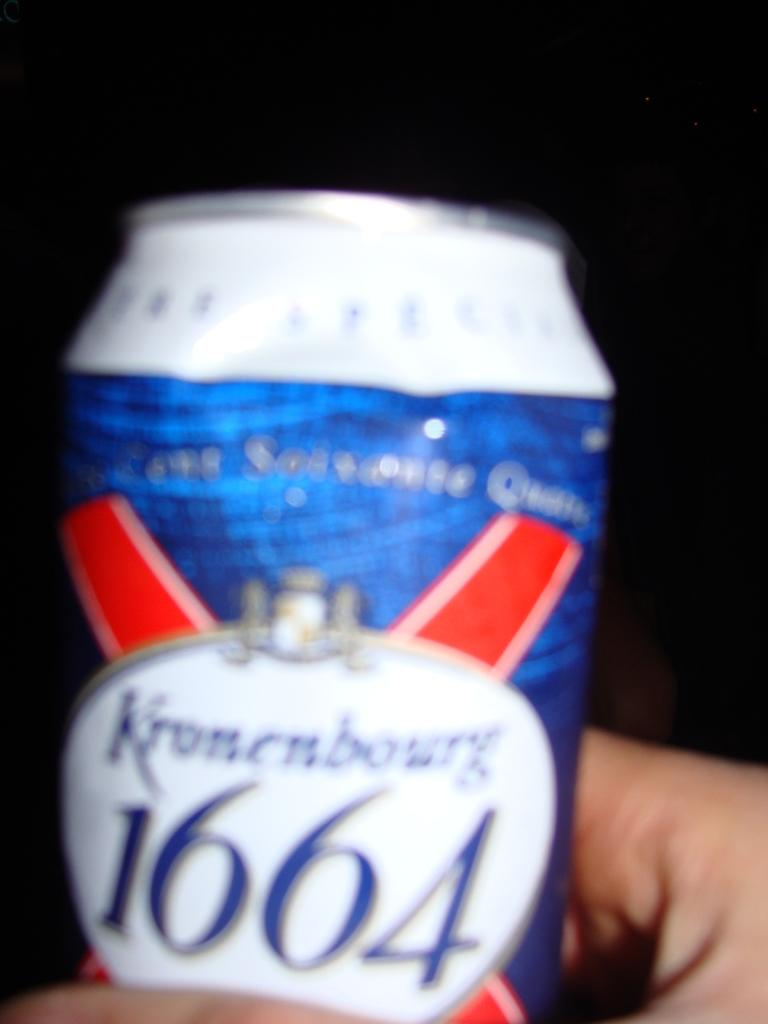<image>
Describe the image concisely. the year 1664 is on the front of the can 